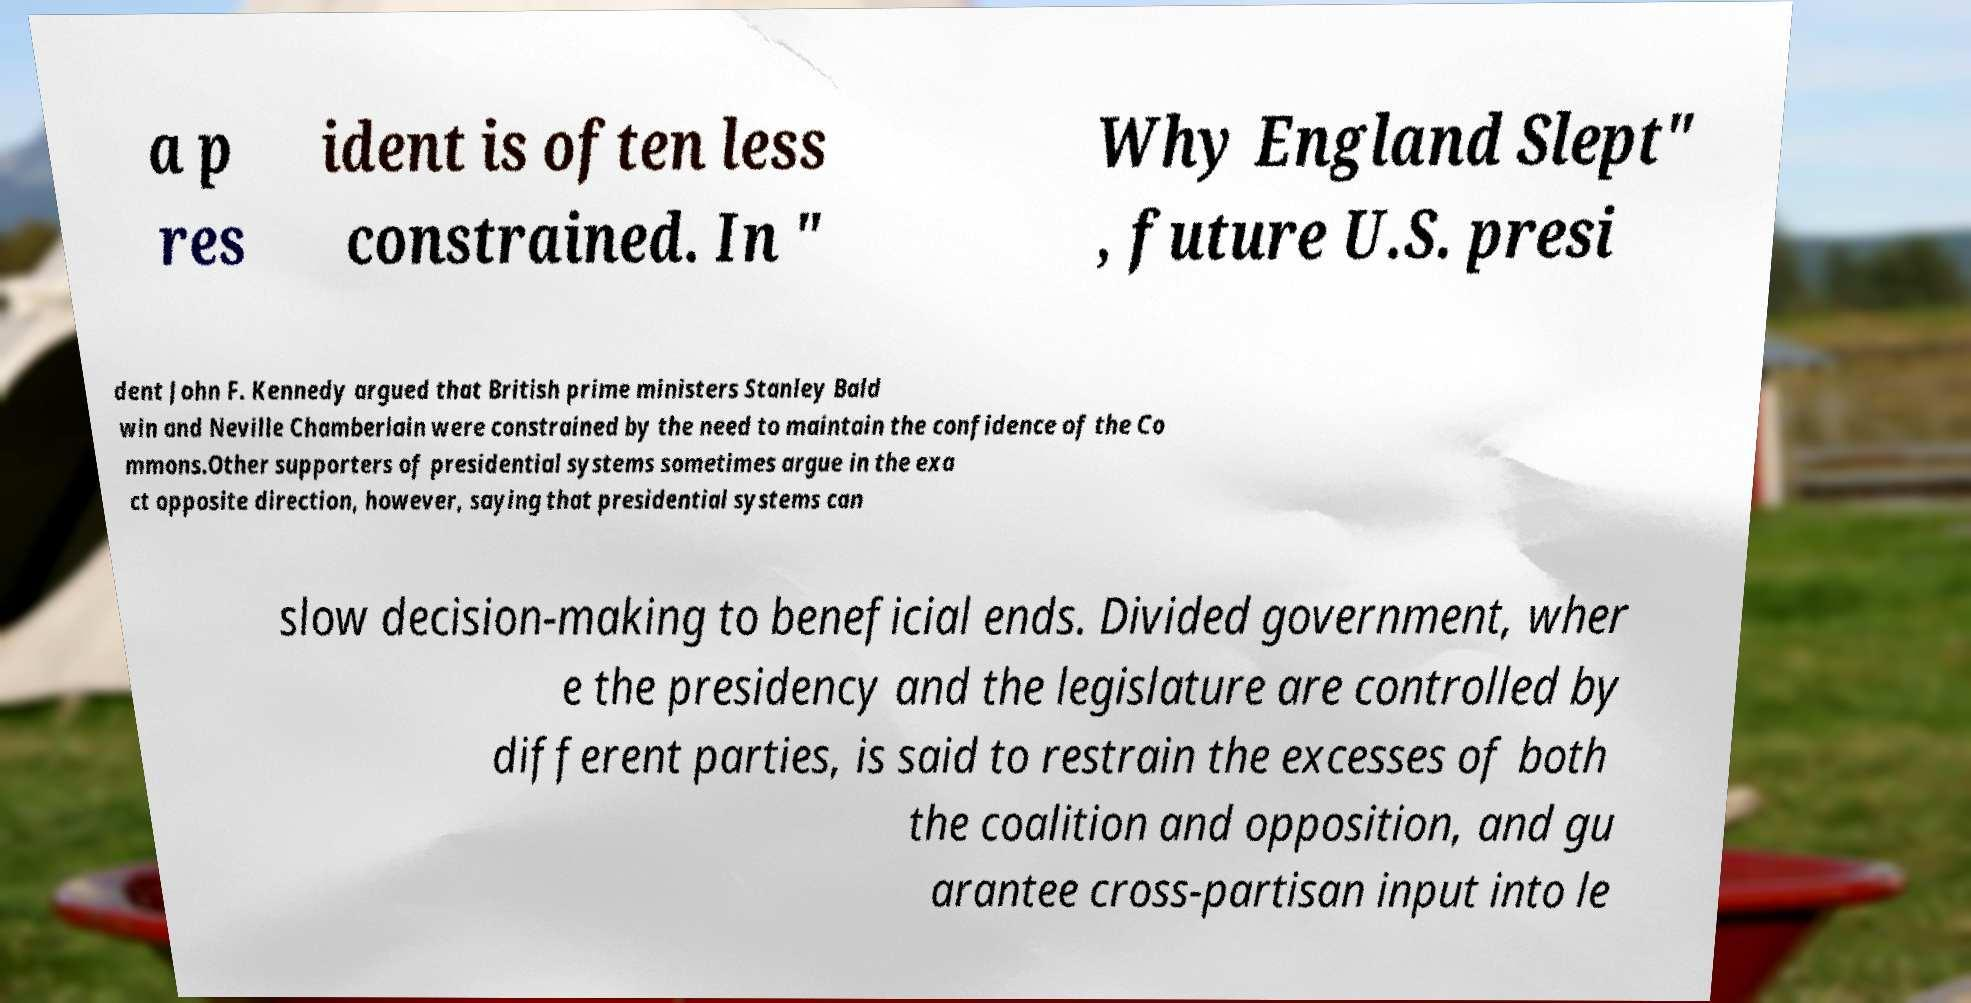Could you extract and type out the text from this image? a p res ident is often less constrained. In " Why England Slept" , future U.S. presi dent John F. Kennedy argued that British prime ministers Stanley Bald win and Neville Chamberlain were constrained by the need to maintain the confidence of the Co mmons.Other supporters of presidential systems sometimes argue in the exa ct opposite direction, however, saying that presidential systems can slow decision-making to beneficial ends. Divided government, wher e the presidency and the legislature are controlled by different parties, is said to restrain the excesses of both the coalition and opposition, and gu arantee cross-partisan input into le 